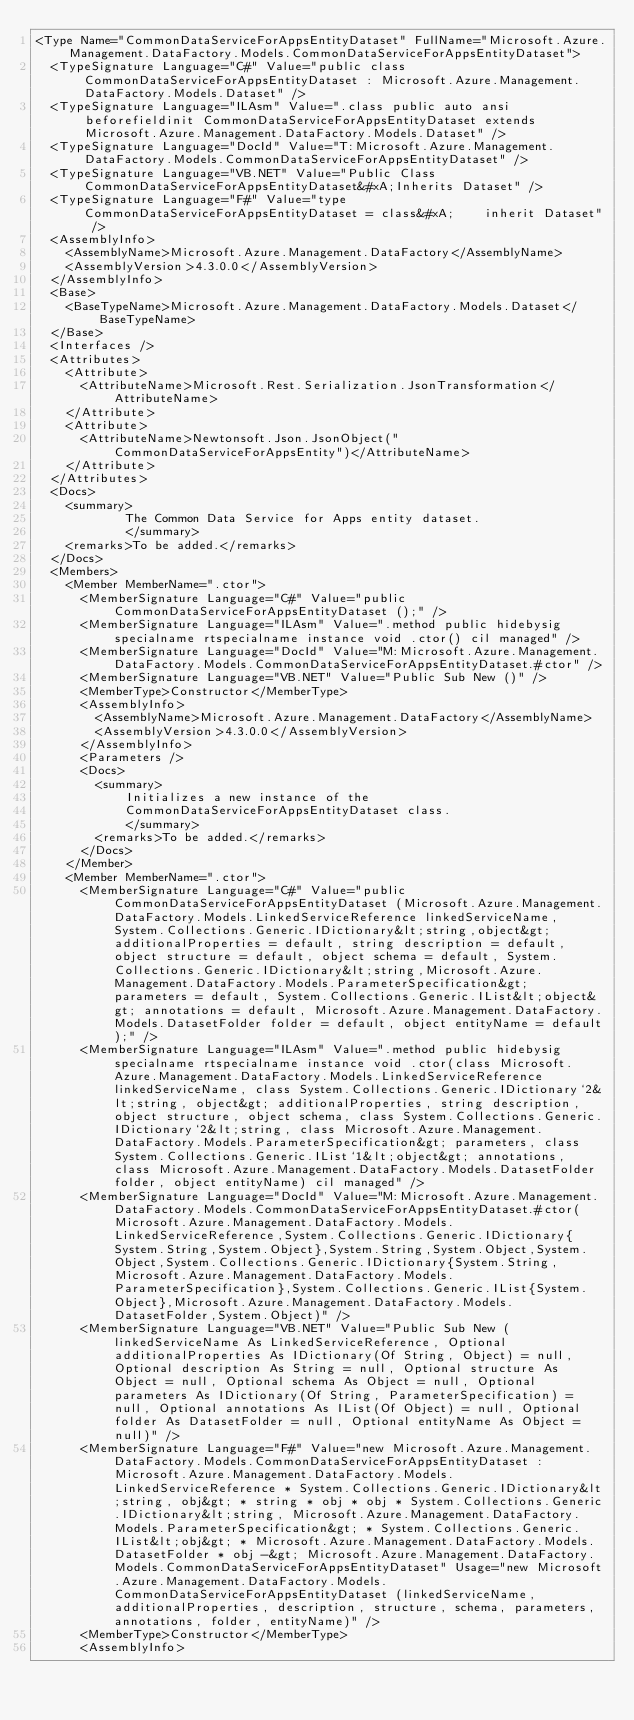<code> <loc_0><loc_0><loc_500><loc_500><_XML_><Type Name="CommonDataServiceForAppsEntityDataset" FullName="Microsoft.Azure.Management.DataFactory.Models.CommonDataServiceForAppsEntityDataset">
  <TypeSignature Language="C#" Value="public class CommonDataServiceForAppsEntityDataset : Microsoft.Azure.Management.DataFactory.Models.Dataset" />
  <TypeSignature Language="ILAsm" Value=".class public auto ansi beforefieldinit CommonDataServiceForAppsEntityDataset extends Microsoft.Azure.Management.DataFactory.Models.Dataset" />
  <TypeSignature Language="DocId" Value="T:Microsoft.Azure.Management.DataFactory.Models.CommonDataServiceForAppsEntityDataset" />
  <TypeSignature Language="VB.NET" Value="Public Class CommonDataServiceForAppsEntityDataset&#xA;Inherits Dataset" />
  <TypeSignature Language="F#" Value="type CommonDataServiceForAppsEntityDataset = class&#xA;    inherit Dataset" />
  <AssemblyInfo>
    <AssemblyName>Microsoft.Azure.Management.DataFactory</AssemblyName>
    <AssemblyVersion>4.3.0.0</AssemblyVersion>
  </AssemblyInfo>
  <Base>
    <BaseTypeName>Microsoft.Azure.Management.DataFactory.Models.Dataset</BaseTypeName>
  </Base>
  <Interfaces />
  <Attributes>
    <Attribute>
      <AttributeName>Microsoft.Rest.Serialization.JsonTransformation</AttributeName>
    </Attribute>
    <Attribute>
      <AttributeName>Newtonsoft.Json.JsonObject("CommonDataServiceForAppsEntity")</AttributeName>
    </Attribute>
  </Attributes>
  <Docs>
    <summary>
            The Common Data Service for Apps entity dataset.
            </summary>
    <remarks>To be added.</remarks>
  </Docs>
  <Members>
    <Member MemberName=".ctor">
      <MemberSignature Language="C#" Value="public CommonDataServiceForAppsEntityDataset ();" />
      <MemberSignature Language="ILAsm" Value=".method public hidebysig specialname rtspecialname instance void .ctor() cil managed" />
      <MemberSignature Language="DocId" Value="M:Microsoft.Azure.Management.DataFactory.Models.CommonDataServiceForAppsEntityDataset.#ctor" />
      <MemberSignature Language="VB.NET" Value="Public Sub New ()" />
      <MemberType>Constructor</MemberType>
      <AssemblyInfo>
        <AssemblyName>Microsoft.Azure.Management.DataFactory</AssemblyName>
        <AssemblyVersion>4.3.0.0</AssemblyVersion>
      </AssemblyInfo>
      <Parameters />
      <Docs>
        <summary>
            Initializes a new instance of the
            CommonDataServiceForAppsEntityDataset class.
            </summary>
        <remarks>To be added.</remarks>
      </Docs>
    </Member>
    <Member MemberName=".ctor">
      <MemberSignature Language="C#" Value="public CommonDataServiceForAppsEntityDataset (Microsoft.Azure.Management.DataFactory.Models.LinkedServiceReference linkedServiceName, System.Collections.Generic.IDictionary&lt;string,object&gt; additionalProperties = default, string description = default, object structure = default, object schema = default, System.Collections.Generic.IDictionary&lt;string,Microsoft.Azure.Management.DataFactory.Models.ParameterSpecification&gt; parameters = default, System.Collections.Generic.IList&lt;object&gt; annotations = default, Microsoft.Azure.Management.DataFactory.Models.DatasetFolder folder = default, object entityName = default);" />
      <MemberSignature Language="ILAsm" Value=".method public hidebysig specialname rtspecialname instance void .ctor(class Microsoft.Azure.Management.DataFactory.Models.LinkedServiceReference linkedServiceName, class System.Collections.Generic.IDictionary`2&lt;string, object&gt; additionalProperties, string description, object structure, object schema, class System.Collections.Generic.IDictionary`2&lt;string, class Microsoft.Azure.Management.DataFactory.Models.ParameterSpecification&gt; parameters, class System.Collections.Generic.IList`1&lt;object&gt; annotations, class Microsoft.Azure.Management.DataFactory.Models.DatasetFolder folder, object entityName) cil managed" />
      <MemberSignature Language="DocId" Value="M:Microsoft.Azure.Management.DataFactory.Models.CommonDataServiceForAppsEntityDataset.#ctor(Microsoft.Azure.Management.DataFactory.Models.LinkedServiceReference,System.Collections.Generic.IDictionary{System.String,System.Object},System.String,System.Object,System.Object,System.Collections.Generic.IDictionary{System.String,Microsoft.Azure.Management.DataFactory.Models.ParameterSpecification},System.Collections.Generic.IList{System.Object},Microsoft.Azure.Management.DataFactory.Models.DatasetFolder,System.Object)" />
      <MemberSignature Language="VB.NET" Value="Public Sub New (linkedServiceName As LinkedServiceReference, Optional additionalProperties As IDictionary(Of String, Object) = null, Optional description As String = null, Optional structure As Object = null, Optional schema As Object = null, Optional parameters As IDictionary(Of String, ParameterSpecification) = null, Optional annotations As IList(Of Object) = null, Optional folder As DatasetFolder = null, Optional entityName As Object = null)" />
      <MemberSignature Language="F#" Value="new Microsoft.Azure.Management.DataFactory.Models.CommonDataServiceForAppsEntityDataset : Microsoft.Azure.Management.DataFactory.Models.LinkedServiceReference * System.Collections.Generic.IDictionary&lt;string, obj&gt; * string * obj * obj * System.Collections.Generic.IDictionary&lt;string, Microsoft.Azure.Management.DataFactory.Models.ParameterSpecification&gt; * System.Collections.Generic.IList&lt;obj&gt; * Microsoft.Azure.Management.DataFactory.Models.DatasetFolder * obj -&gt; Microsoft.Azure.Management.DataFactory.Models.CommonDataServiceForAppsEntityDataset" Usage="new Microsoft.Azure.Management.DataFactory.Models.CommonDataServiceForAppsEntityDataset (linkedServiceName, additionalProperties, description, structure, schema, parameters, annotations, folder, entityName)" />
      <MemberType>Constructor</MemberType>
      <AssemblyInfo></code> 